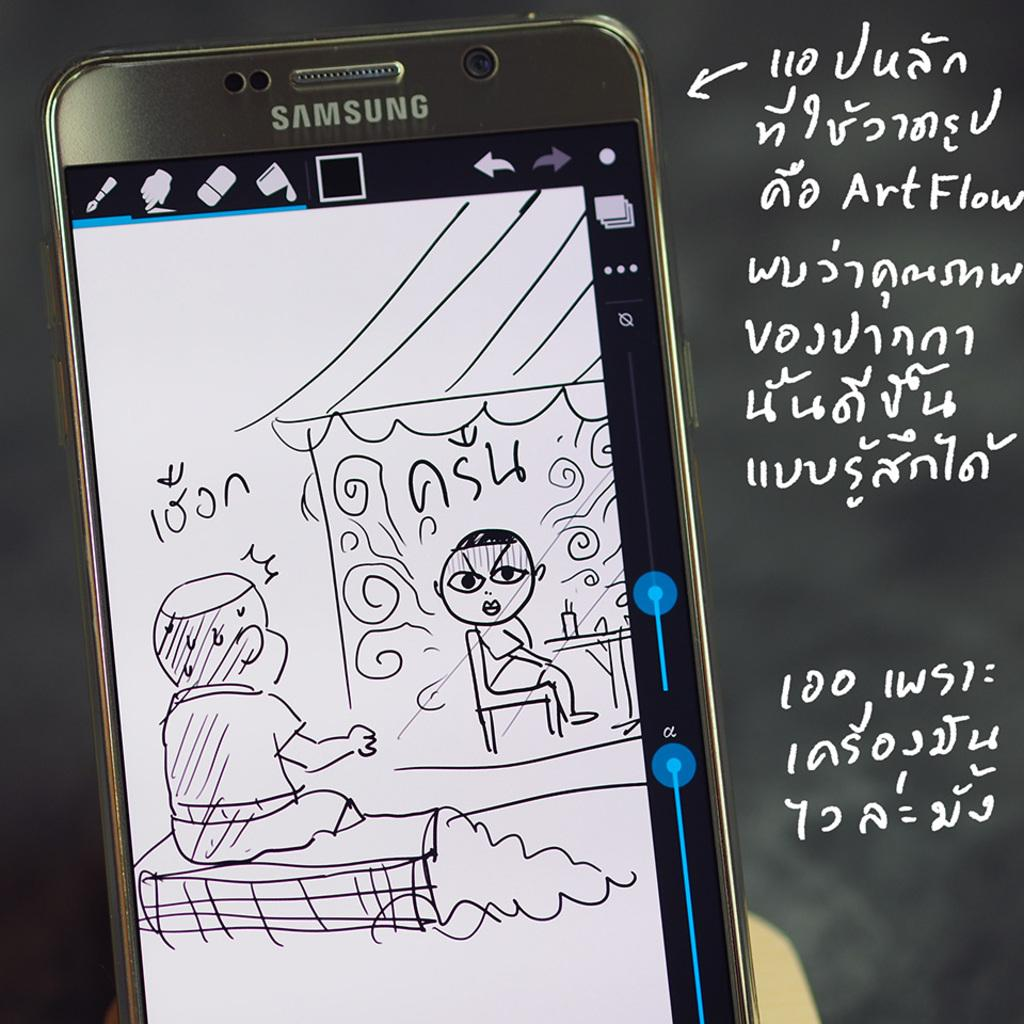<image>
Present a compact description of the photo's key features. A Samsung device with a cartoon on the screen. 